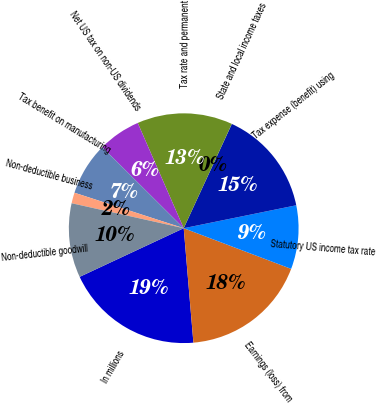<chart> <loc_0><loc_0><loc_500><loc_500><pie_chart><fcel>In millions<fcel>Earnings (loss) from<fcel>Statutory US income tax rate<fcel>Tax expense (benefit) using<fcel>State and local income taxes<fcel>Tax rate and permanent<fcel>Net US tax on non-US dividends<fcel>Tax benefit on manufacturing<fcel>Non-deductible business<fcel>Non-deductible goodwill<nl><fcel>19.39%<fcel>17.9%<fcel>8.96%<fcel>14.92%<fcel>0.01%<fcel>13.43%<fcel>5.98%<fcel>7.47%<fcel>1.51%<fcel>10.45%<nl></chart> 